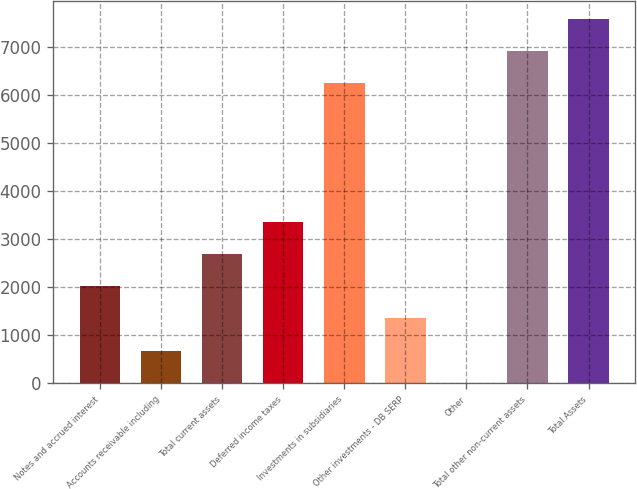<chart> <loc_0><loc_0><loc_500><loc_500><bar_chart><fcel>Notes and accrued interest<fcel>Accounts receivable including<fcel>Total current assets<fcel>Deferred income taxes<fcel>Investments in subsidiaries<fcel>Other investments - DB SERP<fcel>Other<fcel>Total other non-current assets<fcel>Total Assets<nl><fcel>2015.9<fcel>675.3<fcel>2686.2<fcel>3356.5<fcel>6240<fcel>1345.6<fcel>5<fcel>6910.3<fcel>7580.6<nl></chart> 